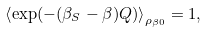Convert formula to latex. <formula><loc_0><loc_0><loc_500><loc_500>\left \langle \exp ( - ( \beta _ { S } - \beta ) Q ) \right \rangle _ { \rho _ { \beta 0 } } = 1 ,</formula> 